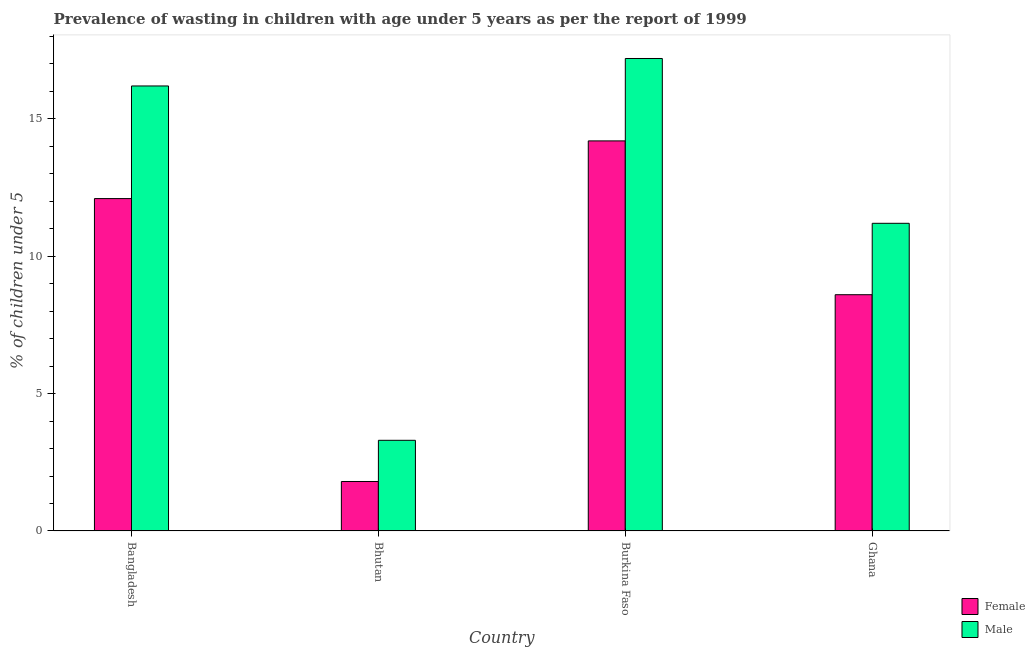How many groups of bars are there?
Keep it short and to the point. 4. How many bars are there on the 3rd tick from the left?
Give a very brief answer. 2. How many bars are there on the 2nd tick from the right?
Give a very brief answer. 2. What is the percentage of undernourished male children in Ghana?
Make the answer very short. 11.2. Across all countries, what is the maximum percentage of undernourished male children?
Make the answer very short. 17.2. Across all countries, what is the minimum percentage of undernourished female children?
Offer a very short reply. 1.8. In which country was the percentage of undernourished male children maximum?
Your answer should be very brief. Burkina Faso. In which country was the percentage of undernourished female children minimum?
Provide a short and direct response. Bhutan. What is the total percentage of undernourished male children in the graph?
Provide a succinct answer. 47.9. What is the difference between the percentage of undernourished female children in Bangladesh and that in Burkina Faso?
Keep it short and to the point. -2.1. What is the difference between the percentage of undernourished male children in Bangladesh and the percentage of undernourished female children in Bhutan?
Your answer should be compact. 14.4. What is the average percentage of undernourished male children per country?
Provide a succinct answer. 11.98. What is the difference between the percentage of undernourished male children and percentage of undernourished female children in Burkina Faso?
Provide a succinct answer. 3. In how many countries, is the percentage of undernourished male children greater than 10 %?
Keep it short and to the point. 3. What is the ratio of the percentage of undernourished male children in Bangladesh to that in Bhutan?
Give a very brief answer. 4.91. Is the percentage of undernourished female children in Burkina Faso less than that in Ghana?
Provide a short and direct response. No. What is the difference between the highest and the second highest percentage of undernourished female children?
Keep it short and to the point. 2.1. What is the difference between the highest and the lowest percentage of undernourished female children?
Ensure brevity in your answer.  12.4. In how many countries, is the percentage of undernourished male children greater than the average percentage of undernourished male children taken over all countries?
Offer a very short reply. 2. How many bars are there?
Ensure brevity in your answer.  8. Does the graph contain any zero values?
Make the answer very short. No. Does the graph contain grids?
Provide a succinct answer. No. How many legend labels are there?
Provide a succinct answer. 2. How are the legend labels stacked?
Offer a terse response. Vertical. What is the title of the graph?
Provide a short and direct response. Prevalence of wasting in children with age under 5 years as per the report of 1999. What is the label or title of the Y-axis?
Your response must be concise.  % of children under 5. What is the  % of children under 5 of Female in Bangladesh?
Make the answer very short. 12.1. What is the  % of children under 5 of Male in Bangladesh?
Your answer should be very brief. 16.2. What is the  % of children under 5 of Female in Bhutan?
Your answer should be compact. 1.8. What is the  % of children under 5 in Male in Bhutan?
Your response must be concise. 3.3. What is the  % of children under 5 of Female in Burkina Faso?
Offer a very short reply. 14.2. What is the  % of children under 5 of Male in Burkina Faso?
Keep it short and to the point. 17.2. What is the  % of children under 5 in Female in Ghana?
Your response must be concise. 8.6. What is the  % of children under 5 in Male in Ghana?
Offer a terse response. 11.2. Across all countries, what is the maximum  % of children under 5 in Female?
Offer a very short reply. 14.2. Across all countries, what is the maximum  % of children under 5 in Male?
Give a very brief answer. 17.2. Across all countries, what is the minimum  % of children under 5 in Female?
Make the answer very short. 1.8. Across all countries, what is the minimum  % of children under 5 in Male?
Provide a succinct answer. 3.3. What is the total  % of children under 5 in Female in the graph?
Provide a succinct answer. 36.7. What is the total  % of children under 5 in Male in the graph?
Your answer should be very brief. 47.9. What is the difference between the  % of children under 5 in Male in Bangladesh and that in Burkina Faso?
Ensure brevity in your answer.  -1. What is the difference between the  % of children under 5 in Female in Bangladesh and that in Ghana?
Ensure brevity in your answer.  3.5. What is the difference between the  % of children under 5 in Female in Bhutan and that in Burkina Faso?
Provide a short and direct response. -12.4. What is the difference between the  % of children under 5 in Female in Bhutan and that in Ghana?
Offer a very short reply. -6.8. What is the difference between the  % of children under 5 of Female in Burkina Faso and that in Ghana?
Offer a terse response. 5.6. What is the difference between the  % of children under 5 of Female in Bangladesh and the  % of children under 5 of Male in Bhutan?
Make the answer very short. 8.8. What is the difference between the  % of children under 5 in Female in Bangladesh and the  % of children under 5 in Male in Burkina Faso?
Ensure brevity in your answer.  -5.1. What is the difference between the  % of children under 5 of Female in Bhutan and the  % of children under 5 of Male in Burkina Faso?
Your answer should be very brief. -15.4. What is the difference between the  % of children under 5 in Female in Bhutan and the  % of children under 5 in Male in Ghana?
Give a very brief answer. -9.4. What is the average  % of children under 5 of Female per country?
Provide a succinct answer. 9.18. What is the average  % of children under 5 of Male per country?
Keep it short and to the point. 11.97. What is the difference between the  % of children under 5 of Female and  % of children under 5 of Male in Burkina Faso?
Keep it short and to the point. -3. What is the ratio of the  % of children under 5 in Female in Bangladesh to that in Bhutan?
Keep it short and to the point. 6.72. What is the ratio of the  % of children under 5 of Male in Bangladesh to that in Bhutan?
Ensure brevity in your answer.  4.91. What is the ratio of the  % of children under 5 of Female in Bangladesh to that in Burkina Faso?
Your answer should be compact. 0.85. What is the ratio of the  % of children under 5 in Male in Bangladesh to that in Burkina Faso?
Make the answer very short. 0.94. What is the ratio of the  % of children under 5 of Female in Bangladesh to that in Ghana?
Make the answer very short. 1.41. What is the ratio of the  % of children under 5 in Male in Bangladesh to that in Ghana?
Make the answer very short. 1.45. What is the ratio of the  % of children under 5 of Female in Bhutan to that in Burkina Faso?
Make the answer very short. 0.13. What is the ratio of the  % of children under 5 in Male in Bhutan to that in Burkina Faso?
Keep it short and to the point. 0.19. What is the ratio of the  % of children under 5 of Female in Bhutan to that in Ghana?
Provide a short and direct response. 0.21. What is the ratio of the  % of children under 5 of Male in Bhutan to that in Ghana?
Ensure brevity in your answer.  0.29. What is the ratio of the  % of children under 5 of Female in Burkina Faso to that in Ghana?
Keep it short and to the point. 1.65. What is the ratio of the  % of children under 5 of Male in Burkina Faso to that in Ghana?
Your answer should be compact. 1.54. What is the difference between the highest and the second highest  % of children under 5 of Female?
Ensure brevity in your answer.  2.1. What is the difference between the highest and the lowest  % of children under 5 of Female?
Ensure brevity in your answer.  12.4. 